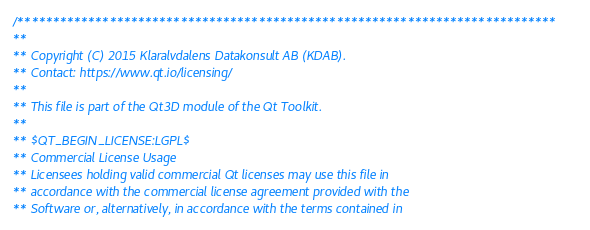<code> <loc_0><loc_0><loc_500><loc_500><_C_>/****************************************************************************
**
** Copyright (C) 2015 Klaralvdalens Datakonsult AB (KDAB).
** Contact: https://www.qt.io/licensing/
**
** This file is part of the Qt3D module of the Qt Toolkit.
**
** $QT_BEGIN_LICENSE:LGPL$
** Commercial License Usage
** Licensees holding valid commercial Qt licenses may use this file in
** accordance with the commercial license agreement provided with the
** Software or, alternatively, in accordance with the terms contained in</code> 